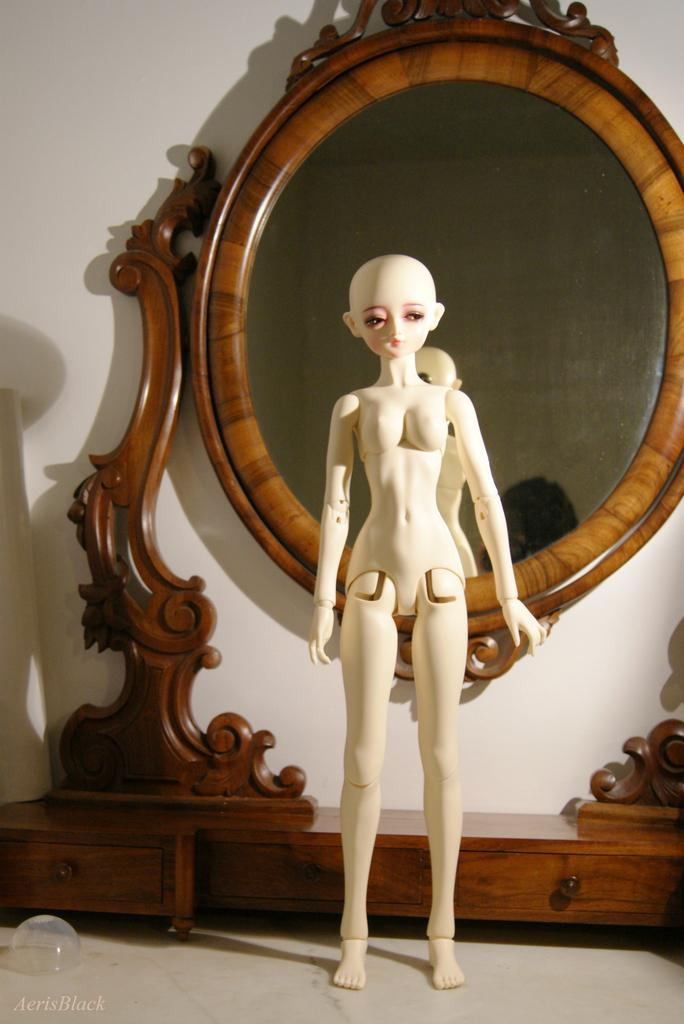What is the main subject in the image? There is a doll standing in the image. What furniture piece is present in the image? There is a mirror with drawers in the image. Can you describe the unspecified object in the image? Unfortunately, the fact only mentions that there is an unspecified object in the image, so we cannot provide more details about it. What can be seen in the background of the image? There is a wall in the background of the image. Is there any additional information about the image itself? Yes, there is a watermark on the image. What type of slope can be seen in the image? There is no slope present in the image; it features a doll, a mirror with drawers, an unspecified object, a wall, and a watermark. What color is the shirt worn by the doll in the image? The fact does not mention a doll wearing a shirt or any clothing at all, so we cannot determine the color of a shirt in the image. 